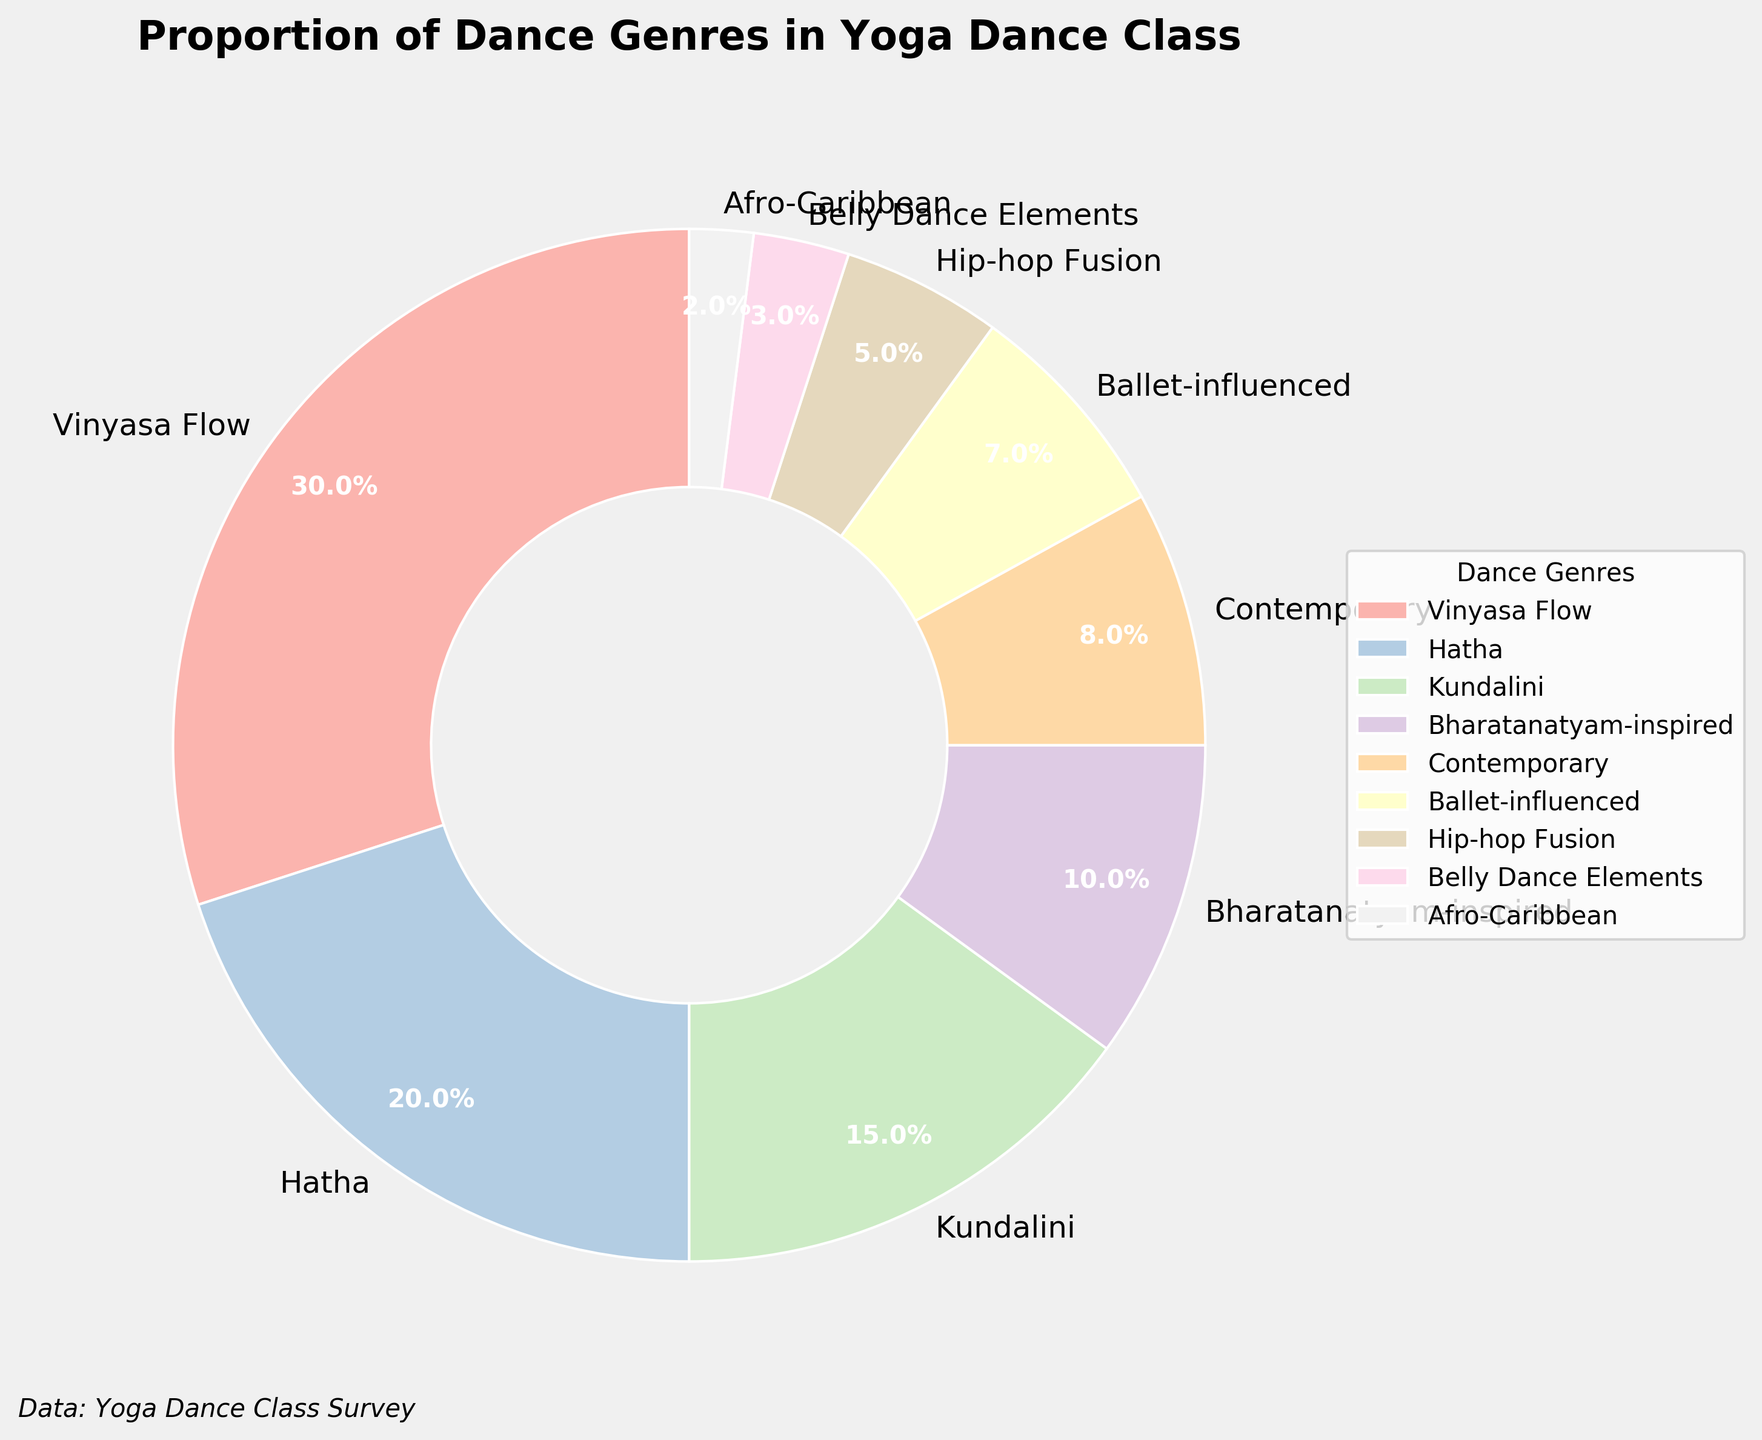Which dance genre has the highest proportion in the yoga dance class? The genre with the highest percentage is Vinyasa Flow at 30%, as indicated by both the label and the size of the corresponding pie slice.
Answer: Vinyasa Flow Which dance genres contribute to at least 50% of the yoga dance class combined? Adding the top genres: Vinyasa Flow (30%), Hatha (20%) makes 50%. These two genres together make up half of the total class content.
Answer: Vinyasa Flow and Hatha What is the difference in percentage between Vinyasa Flow and Hatha genres? Vinyasa Flow has 30% and Hatha has 20%. The difference is 30% - 20% = 10%.
Answer: 10% Are there more contemporary elements or ballet-influenced elements in the yoga dance class? Contemporary elements account for 8% whereas ballet-influenced elements account for 7%, making contemporary elements slightly more prevalent.
Answer: Contemporary elements What proportion of the class features genres with less than 10% each? Summing the genres with less than 10%: 10% + 8% + 7% + 5% + 3% + 2% = 35%.
Answer: 35% Rank the dance genres from the least to the most represented. Ranking them from least to most: Afro-Caribbean (2%), Belly Dance Elements (3%), Hip-hop Fusion (5%), Ballet-influenced (7%), Contemporary (8%), Bharatanatyam-inspired (10%), Kundalini (15%), Hatha (20%), Vinyasa Flow (30%).
Answer: Afro-Caribbean, Belly Dance Elements, Hip-hop Fusion, Ballet-influenced, Contemporary, Bharatanatyam-inspired, Kundalini, Hatha, Vinyasa Flow What is the combined percentage of the Afro-Caribbean and Belly Dance Elements genres? Adding the percentages for Afro-Caribbean (2%) and Belly Dance Elements (3%) gives 2% + 3% = 5%.
Answer: 5% Which sector in the pie chart is visually the smallest in size? Afro-Caribbean is the smallest with only 2%.
Answer: Afro-Caribbean 